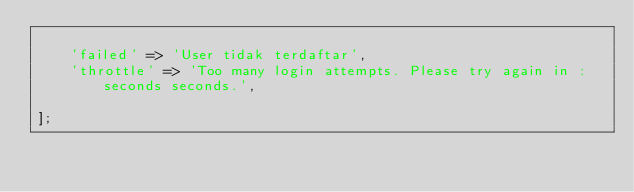<code> <loc_0><loc_0><loc_500><loc_500><_PHP_>
    'failed' => 'User tidak terdaftar',
    'throttle' => 'Too many login attempts. Please try again in :seconds seconds.',

];
</code> 